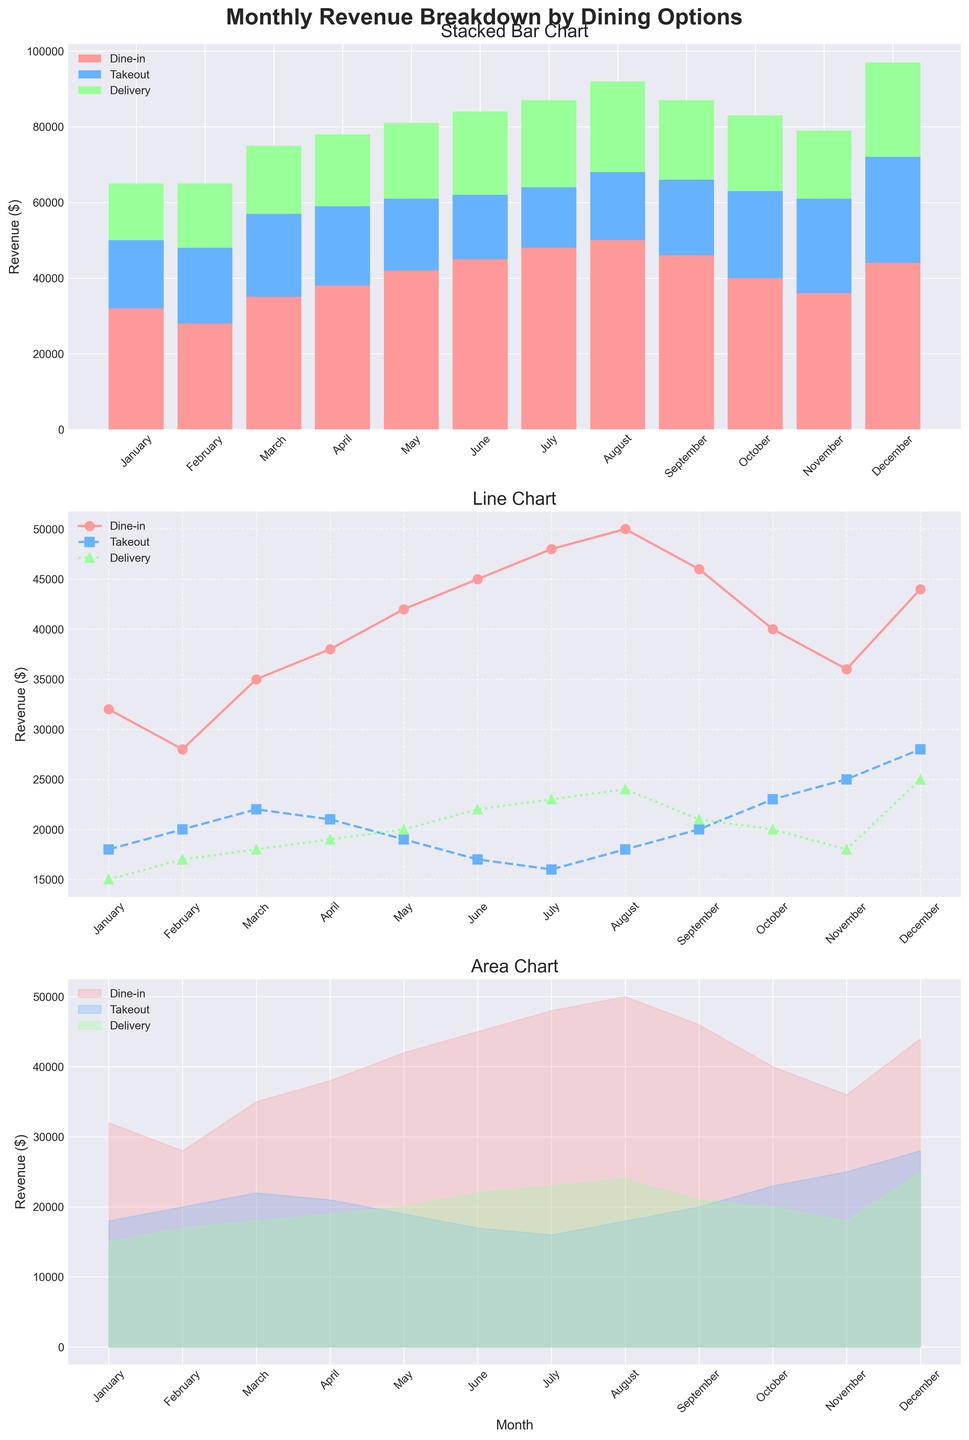What is the title of the overall figure? The title is located at the top center of the figure and reads 'Monthly Revenue Breakdown by Dining Options'.
Answer: Monthly Revenue Breakdown by Dining Options Which month has the highest dine-in revenue in the line chart? In the line chart, the highest point for the dine-in (red line) is in August.
Answer: August What is the combined revenue for takeout and delivery in June as shown in the bar chart? The bar chart shows that takeout revenue is $17,000 and delivery revenue is $22,000 in June. Adding these gives $17,000 + $22,000 = $39,000.
Answer: $39,000 How does the delivery revenue in November compare to October in the line chart? In the line chart, the orange line for delivery shows $18,000 in November and $20,000 in October. November's delivery revenue is $2,000 less than October's.
Answer: $2,000 less What is the total revenue in December according to the area chart? The area chart shows cumulative revenues, so the sum is the final values: Dine-in is $44,000, Takeout is $28,000, and Delivery is $25,000. Total = $44,000 + $28,000 + $25,000 = $97,000.
Answer: $97,000 In which month does takeout revenue reach its peak as seen in the stacked bar chart? The stacked bar chart shows the highest takeout revenue (blue section) in December.
Answer: December Which dining option shows the steepest incline in revenue from January to December in the area chart? The area chart shows delivery revenue (green area) increasing the most sharply from January to December.
Answer: Delivery What is the average dine-in revenue over the 12 months according to the line chart? Add the dine-in revenues for all months and divide by 12: (32000 + 28000 + 35000 + 38000 + 42000 + 45000 + 48000 + 50000 + 46000 + 40000 + 36000 + 44000) / 12 = 4233.33.
Answer: $41,417 How does the total revenue in April compare to June in the stacked bar chart? In April, the total revenue is the sum of dine-in ($38,000), takeout ($21,000), and delivery ($19,000) giving $78,000. For June, it is dine-in ($45,000), takeout ($17,000), and delivery ($22,000) giving $84,000. June's total revenue is $6,000 higher than April's.
Answer: $6,000 higher Which dining option has the most consistent revenue across all months in the line chart? The line chart shows that takeout revenue (blue line) has the least fluctuation compared to dine-in and delivery.
Answer: Takeout 